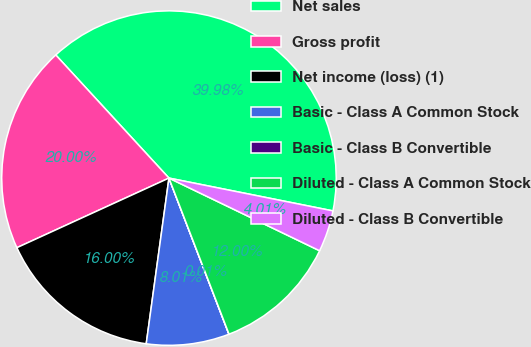<chart> <loc_0><loc_0><loc_500><loc_500><pie_chart><fcel>Net sales<fcel>Gross profit<fcel>Net income (loss) (1)<fcel>Basic - Class A Common Stock<fcel>Basic - Class B Convertible<fcel>Diluted - Class A Common Stock<fcel>Diluted - Class B Convertible<nl><fcel>39.98%<fcel>20.0%<fcel>16.0%<fcel>8.01%<fcel>0.01%<fcel>12.0%<fcel>4.01%<nl></chart> 